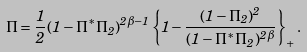Convert formula to latex. <formula><loc_0><loc_0><loc_500><loc_500>\Pi = \frac { 1 } { 2 } ( 1 - \Pi ^ { \ast } \Pi _ { 2 } ) ^ { 2 \beta - 1 } \left \{ 1 - \frac { ( 1 - \Pi _ { 2 } ) ^ { 2 } } { ( 1 - \Pi ^ { \ast } \Pi _ { 2 } ) ^ { 2 \beta } } \right \} _ { + } .</formula> 